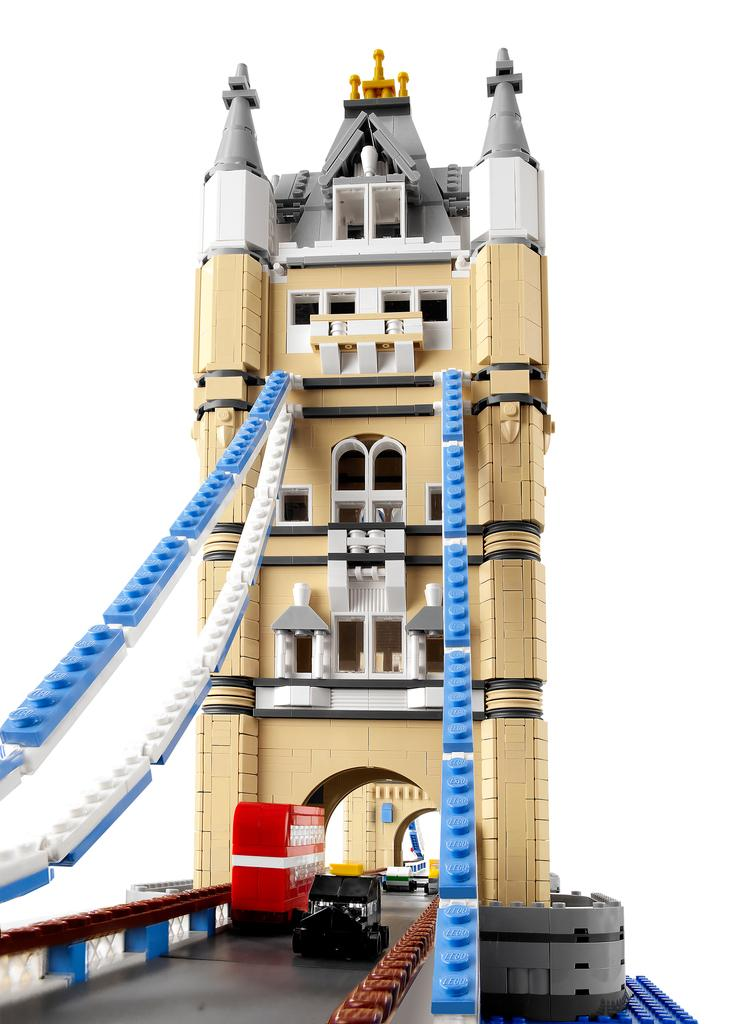What type of toys are featured in the image? There are Lego city toys in the image. What structure can be seen among the Lego city toys? A bridge is present among the Lego city toys. What mode of transportation can be seen on the road in the image? Vehicles are on the road in the image. What color is the background of the image? The background of the image is white in color. What type of thrill can be experienced by the Lego city toys in the image? The Lego city toys in the image are inanimate objects and cannot experience thrills. 